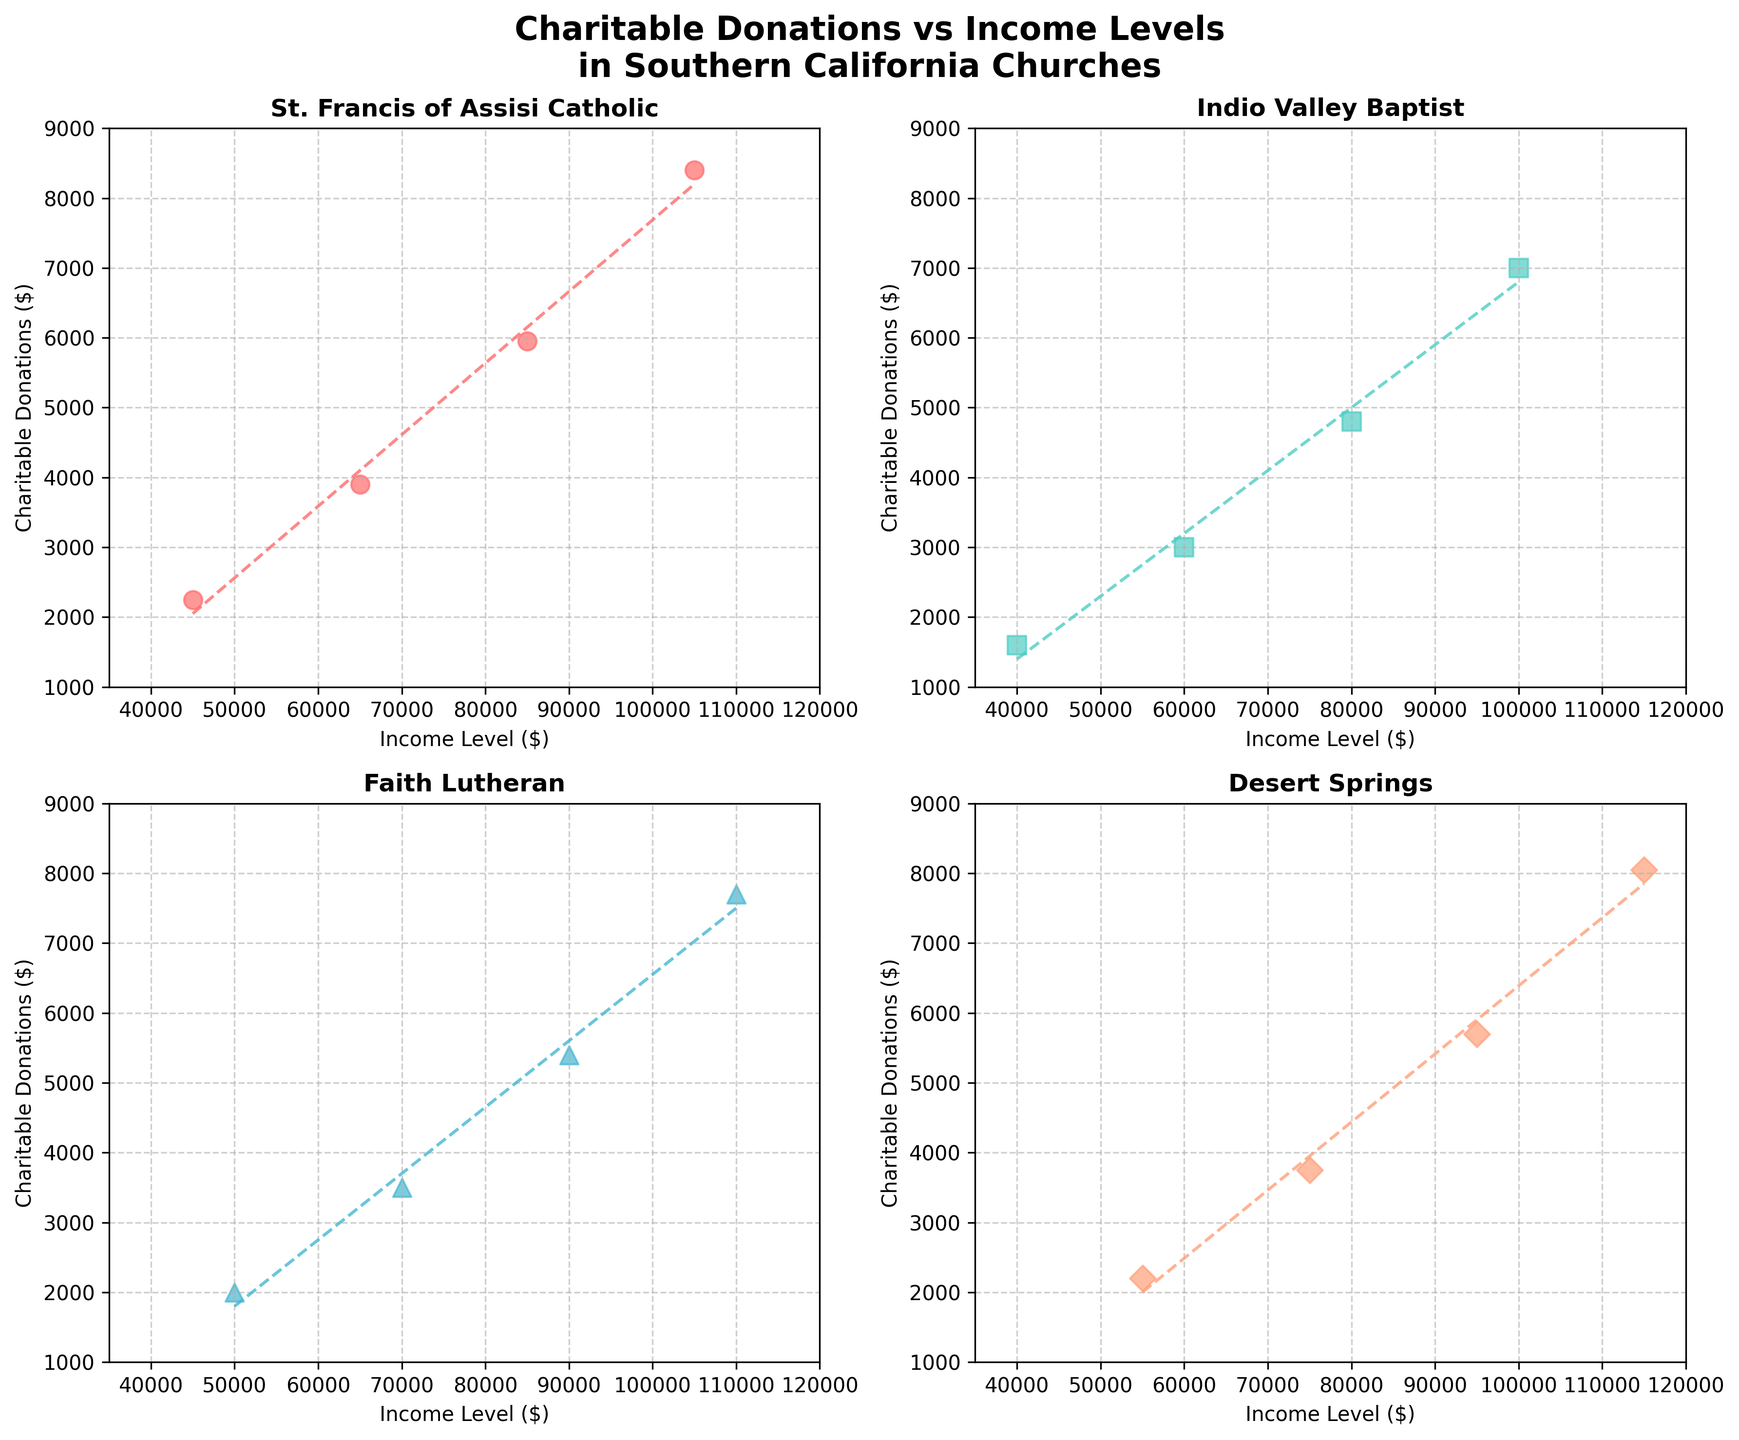What's the title of the overall figure? The title of the overall figure is located at the top center and reads "Charitable Donations vs Income Levels in Southern California Churches" with a subtitle indicating Southern California churches.
Answer: Charitable Donations vs Income Levels in Southern California Churches What is the range of the x-axis (Income Level) in each subplot? By looking at the x-axis labels in each subplot, we can see that the range is consistently from $35,000 to $120,000.
Answer: $35,000 to $120,000 How many data points are plotted for St. Francis of Assisi Catholic Church? By counting the points in the St. Francis of Assisi Catholic Church subplot, we see there are 4 data points.
Answer: 4 Which church has the highest charitable donation at the highest income level plotted? By comparing the highest income level points in each subplot, Desert Springs Church has the highest charitable donation at $115,000 income level, which is $8,050.
Answer: Desert Springs Church Considering the trendlines, which church seems to have the steepest increase in donations relative to income level? By looking at the steepness of the trendlines in each subplot, St. Francis of Assisi Catholic Church has the steepest increase, indicated by the sharp upward slope.
Answer: St. Francis of Assisi Catholic Church What's the average charitable donation for Indio Valley Baptist Church? To find the average, sum all charitable donations for Indio Valley Baptist Church: $1600 + $3000 + $4800 + $7000 = $16400. Then, divide by the number of data points (4). $16400 / 4 = $4100.
Answer: $4100 Which church has the smallest donation at the $90,000 income level? By comparing the donation points corresponding to the $90,000 income level in the subplots, Faith Lutheran Church has the smallest donation at this level, which is $5400.
Answer: Faith Lutheran Church What is the difference in charitable donations between the highest and lowest income levels for Faith Lutheran Church? For Faith Lutheran Church, the highest donation is $7700 at $110,000 income, and the lowest is $2000 at $50,000 income. The difference is $7700 - $2000 = $5700.
Answer: $5700 Which church shows the most linear relationship between Income Level and Charitable Donations? Observing the closeness of the data points to the trendline in each subplot, it appears that Indio Valley Baptist Church shows the most linear relationship.
Answer: Indio Valley Baptist Church 